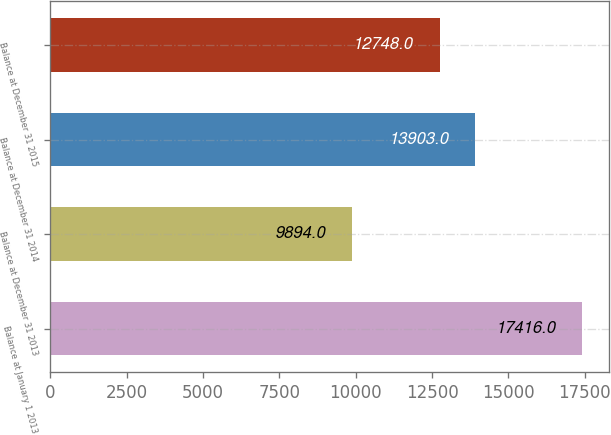<chart> <loc_0><loc_0><loc_500><loc_500><bar_chart><fcel>Balance at January 1 2013<fcel>Balance at December 31 2013<fcel>Balance at December 31 2014<fcel>Balance at December 31 2015<nl><fcel>17416<fcel>9894<fcel>13903<fcel>12748<nl></chart> 